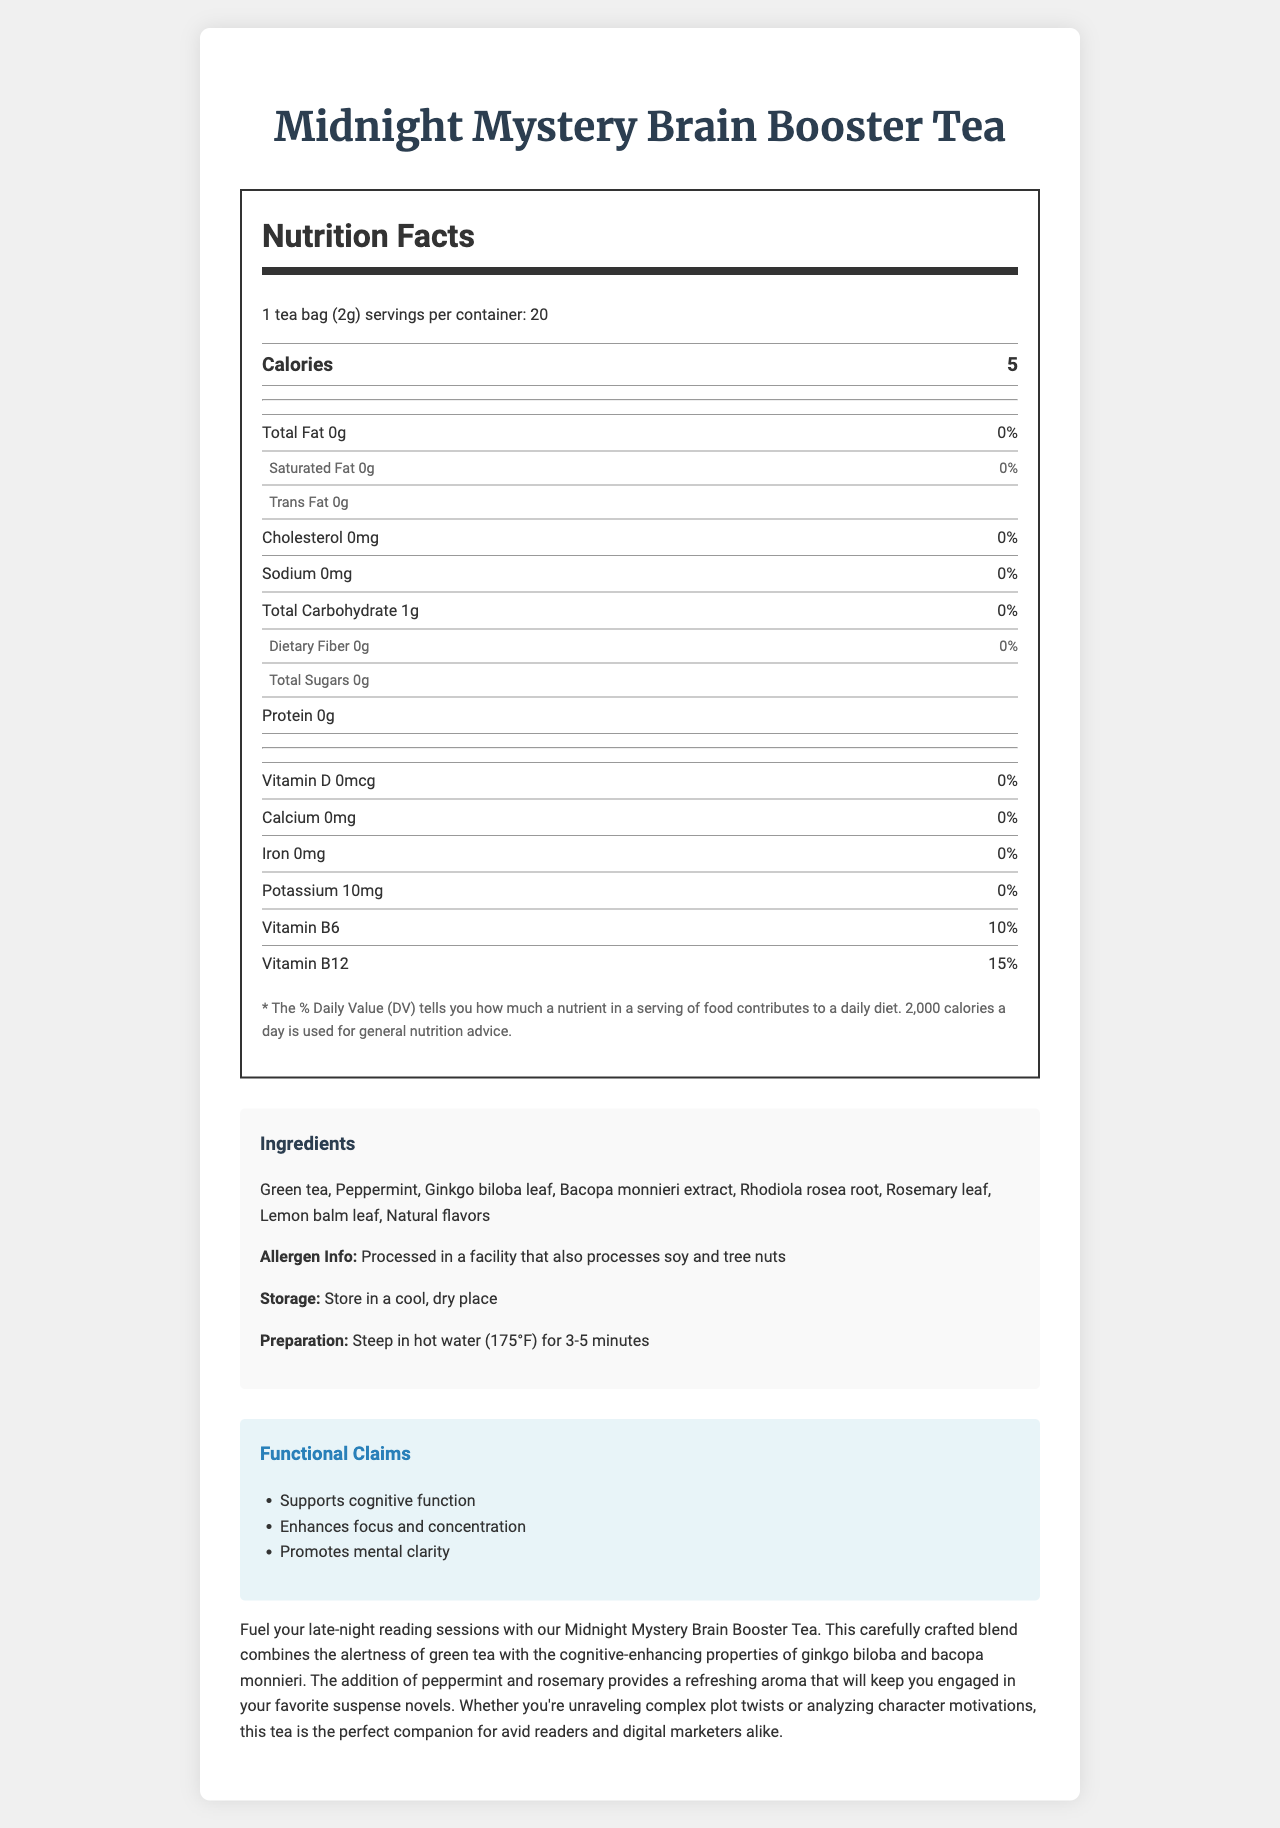what is the product name? The document clearly states that the product name is "Midnight Mystery Brain Booster Tea".
Answer: Midnight Mystery Brain Booster Tea how many calories are in one serving? The Nutritional Facts label indicates that each serving has 5 calories.
Answer: 5 what is the serving size? The serving size is explicitly mentioned as "1 tea bag (2g)".
Answer: 1 tea bag (2g) how much caffeine is in one serving of the tea? The document lists 30 mg of caffeine per serving.
Answer: 30 mg which vitamins and their percentages are listed in the nutritional information? The nutritional information mentions that each serving contains 10% of the daily value for Vitamin B6 and 15% for Vitamin B12.
Answer: Vitamin B6 (10%) and Vitamin B12 (15%) which of the following ingredients is not included in the tea blend? A. Peppermint B. Bacopa monnieri extract C. Chamomile Chamomile is not listed among the ingredients, whereas Peppermint and Bacopa monnieri extract are included.
Answer: C. Chamomile how many servings are there in one container? A. 10 B. 20 C. 30 The nutritional label states that there are 20 servings per container.
Answer: B. 20 can this tea be considered a significant source of Protein? Yes/No The nutrition label shows that the tea contains 0g of protein, indicating it is not a significant source.
Answer: No list two functional claims made about this tea. The document includes three functional claims, out of which "Supports cognitive function" and "Enhances focus and concentration" are two.
Answer: Supports cognitive function, Enhances focus and concentration where is this product processed? The allergen information section specifies that it is processed in a facility that also processes soy and tree nuts.
Answer: In a facility that also processes soy and tree nuts describe the main idea of the document. The explanation summarizes the entirety of the document, covering nutritional details, cognitive benefits, and usage instructions.
Answer: The document provides detailed nutritional information about the "Midnight Mystery Brain Booster Tea", highlighting its ingredients, serving size, and functional claims. It showcases the cognitive benefits that the blend offers, meant to support late-night reading sessions by enhancing focus, concentration, and mental clarity. Additional descriptions include allergen information, storage instructions, and preparation methods. does the document provide information about sugar content in the tea? The nutritional facts indicate that the tea contains 0g of total sugars.
Answer: Yes, it has 0g of total sugars how does this tea benefit avid readers and digital marketers according to the marketing description? The marketing description specifically mentions these benefits, aiming to help with cognitive tasks required by readers and marketers.
Answer: It supports cognitive function, enhances focus and concentration, and promotes mental clarity, essential for engaging in late-night reading and complex analysis. what is the total carbohydrate content per serving? The nutritional facts mention that each serving contains 1g of total carbohydrates.
Answer: 1g how long should you steep the tea for optimal results? The preparation instructions recommend steeping the tea for 3-5 minutes.
Answer: 3-5 minutes how much bacopa monnieri is present in each serving? The document lists 150 mg of Bacopa monnieri per serving as part of the supplementary ingredients.
Answer: 150 mg what is the recommended storage condition for this tea? The storage information advises keeping the product in a cool, dry place.
Answer: Store in a cool, dry place do the nutrition facts labels give information on dietary fiber content? The nutritional facts include dietary fiber content, which is listed as 0g.
Answer: Yes, it has 0g of dietary fiber does this tea contain any allergens? The allergen information on the document states that it is processed in a facility dealing with soy and tree nuts.
Answer: Processed in a facility that also processes soy and tree nuts how much calcium is found in one serving of this tea? The nutritional information indicates that each serving contains 0 mg of calcium.
Answer: 0 mg does the nutritional information specify the sodium content? The document lists the sodium content as 0 mg.
Answer: Yes, it has 0 mg of sodium 